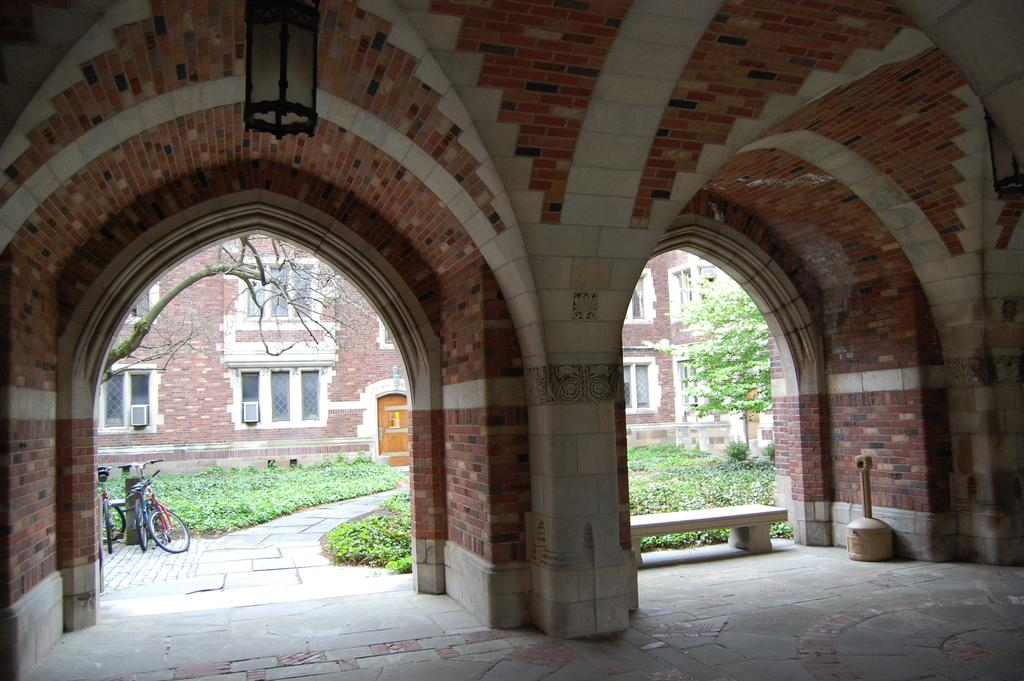What type of structure is in the image? There is a building in the image. What is attached to the building? There are boxes attached to the building. What is on top of the building? There is a light on top of the building. What type of seating is in the image? There is a bench in the image. What type of vegetation is present in the image? Trees and plants are visible in the image. What is visible at the bottom of the image? The ground is visible in the image. Can you describe an unspecified object in the image? There is an unspecified object in the image, but its description is not provided in the facts. What type of bushes can be seen playing in the image? There are no bushes present in the image, and bushes do not play. 